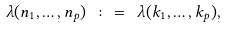<formula> <loc_0><loc_0><loc_500><loc_500>\lambda ( n _ { 1 } , \dots , n _ { p } ) \ \colon = \ \lambda ( k _ { 1 } , \dots , k _ { p } ) ,</formula> 